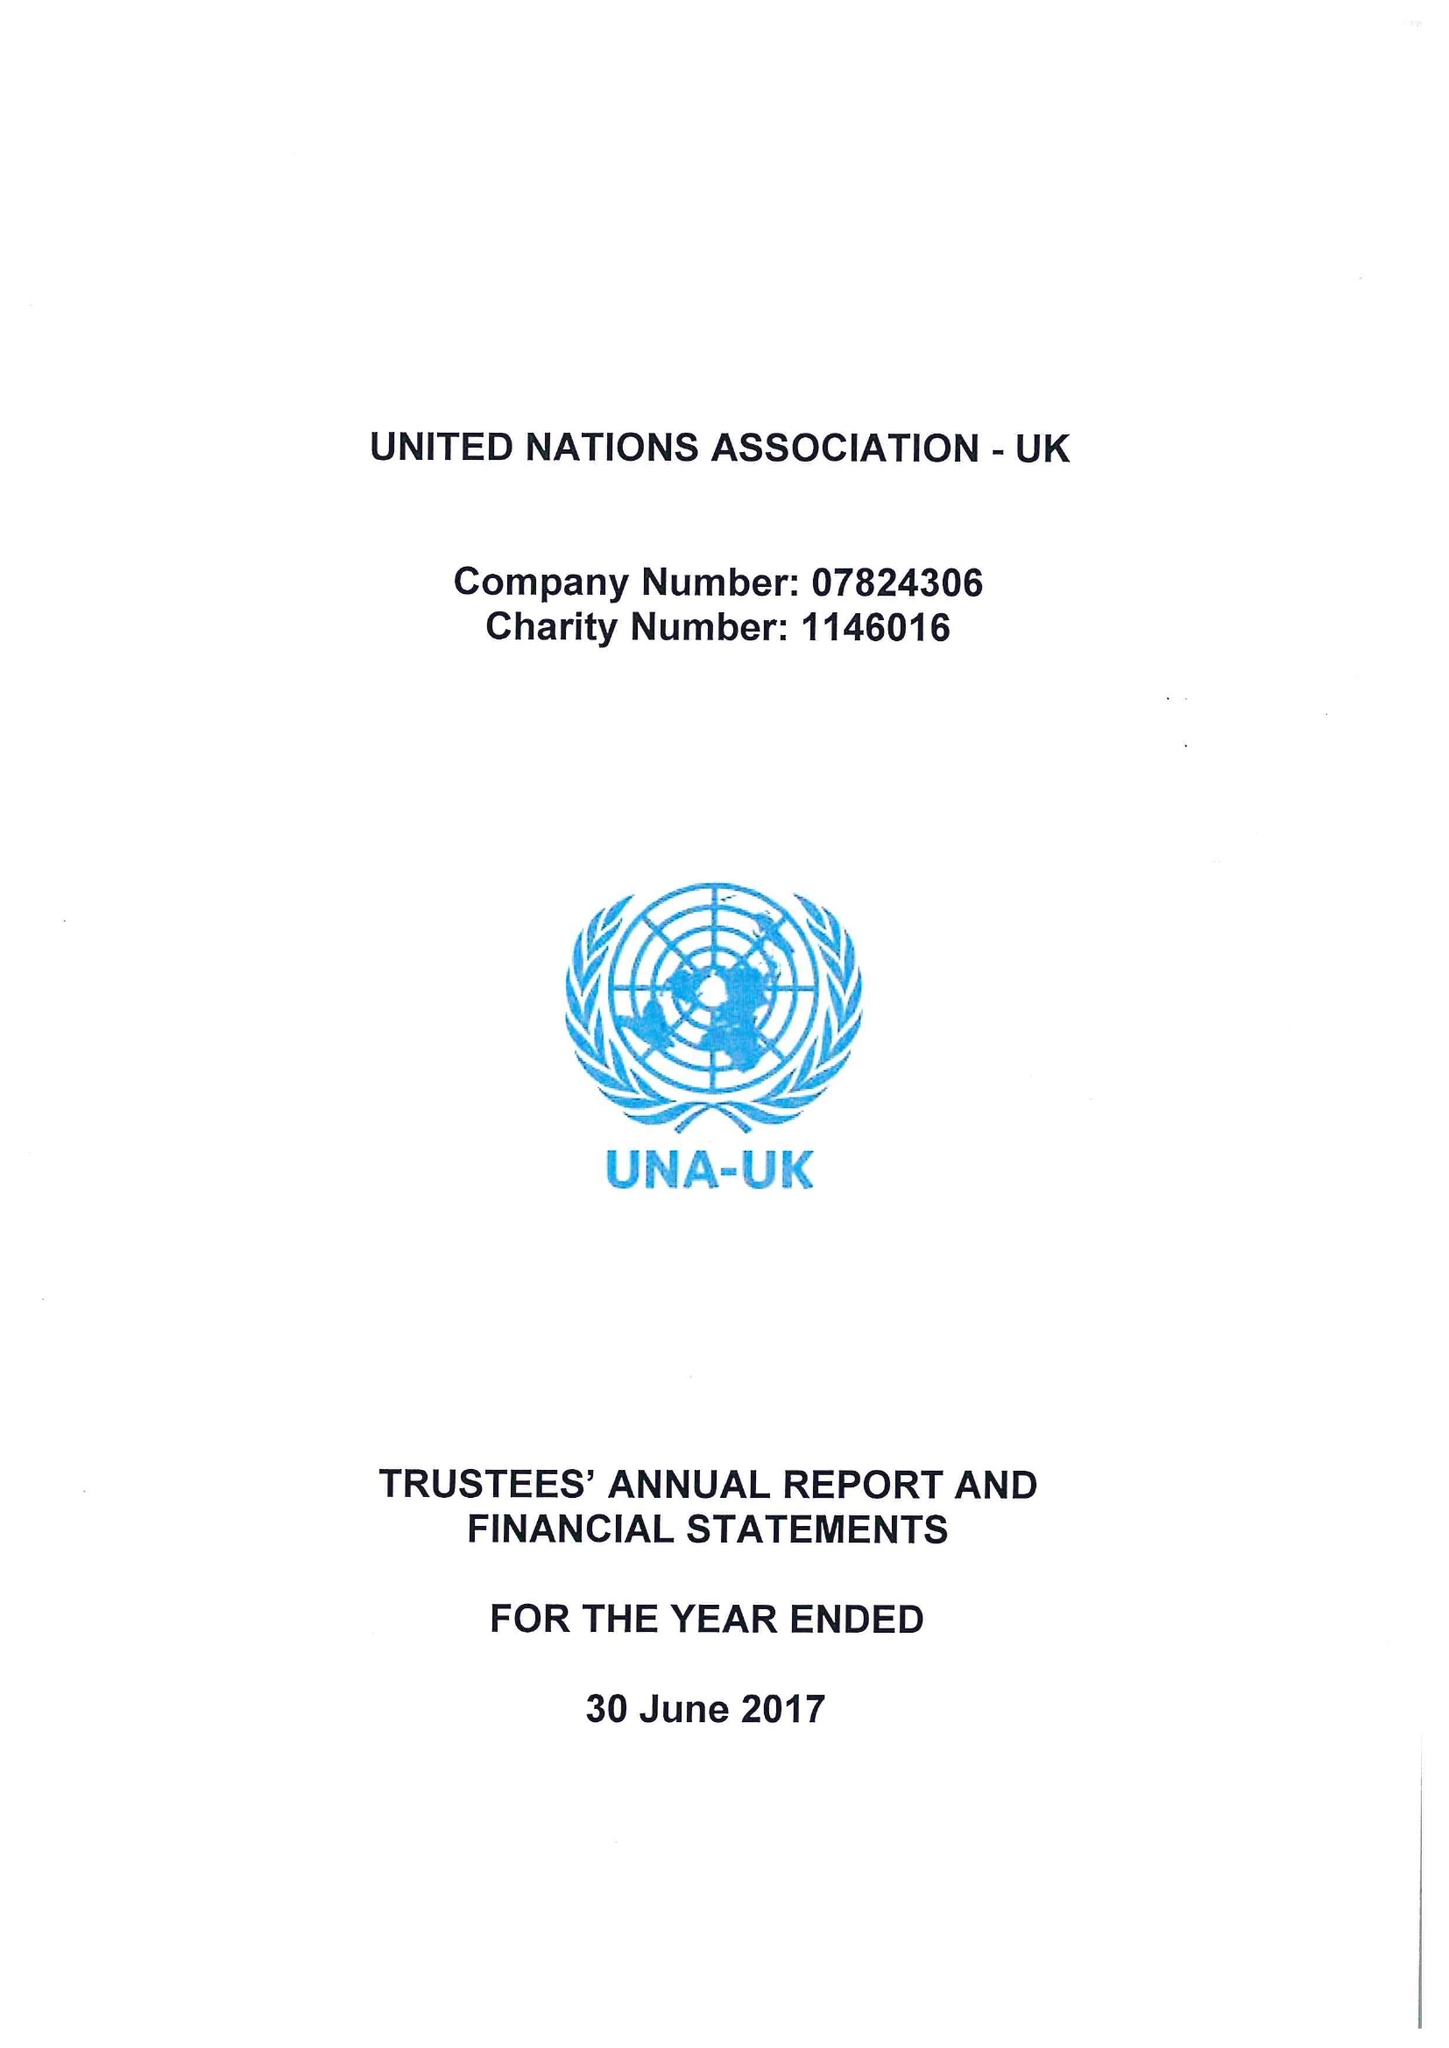What is the value for the charity_name?
Answer the question using a single word or phrase. United Nations Association - Uk 